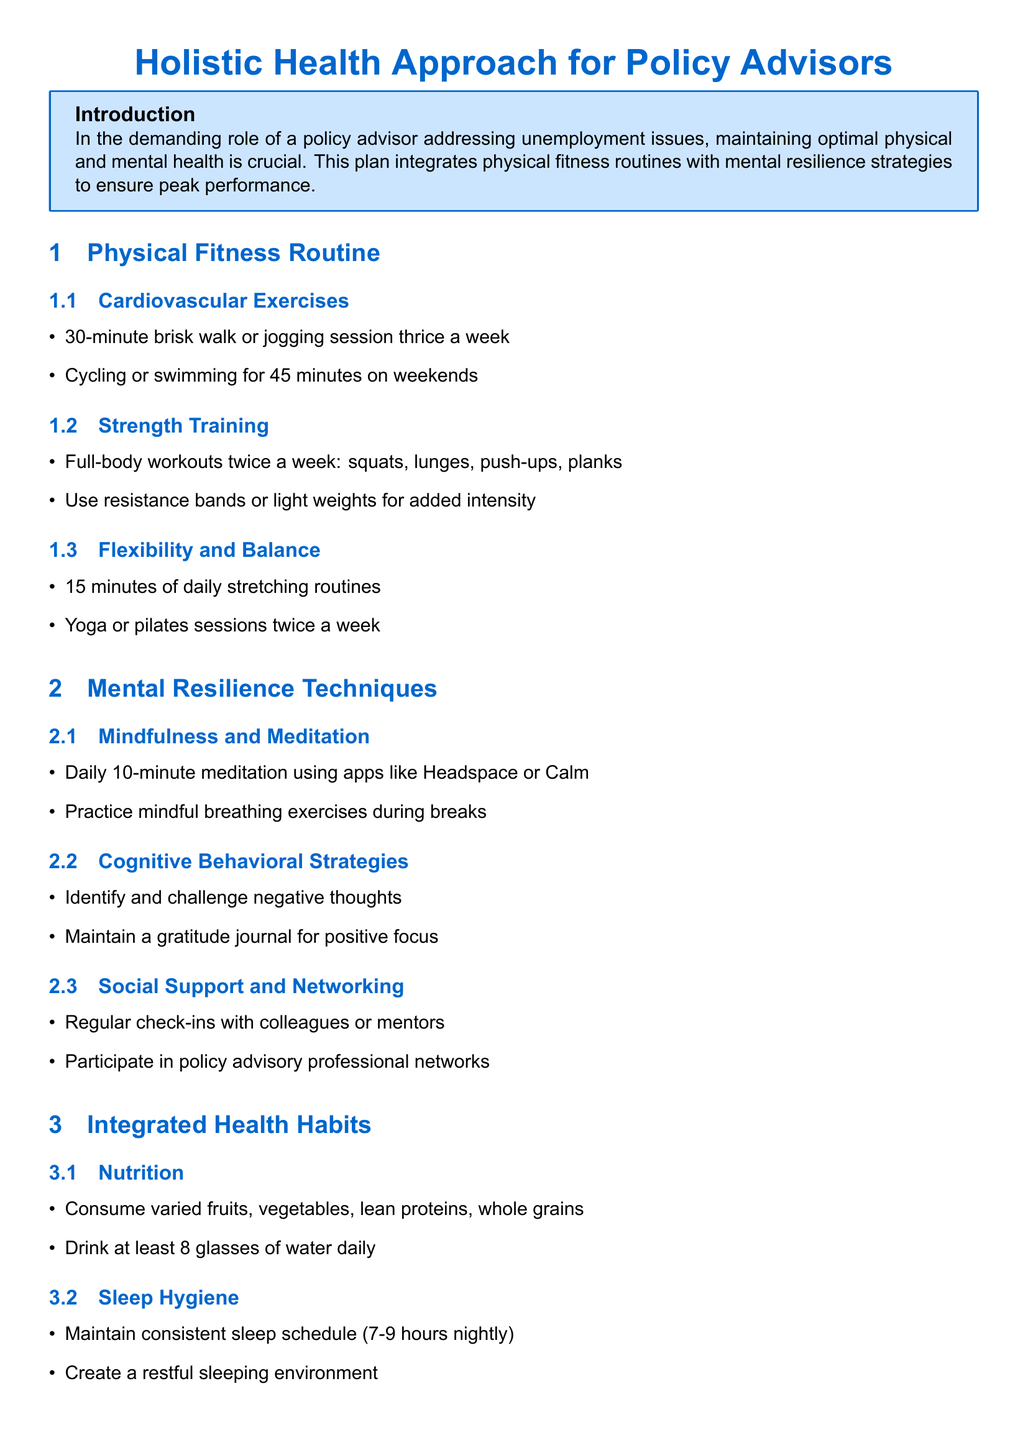what is the recommended frequency for cardiovascular exercises? The document suggests a 30-minute brisk walk or jogging session thrice a week.
Answer: thrice a week how many minutes should be dedicated to daily stretching routines? According to the document, 15 minutes of daily stretching routines are recommended.
Answer: 15 minutes what are two activities recommended for flexibility and balance? The document mentions daily stretching and yoga or pilates sessions twice a week.
Answer: yoga or pilates which app is suggested for daily meditation? The document lists Headspace and Calm as apps for meditation.
Answer: Headspace or Calm what should be maintained for a good sleep hygiene? The document suggests maintaining a consistent sleep schedule of 7-9 hours nightly.
Answer: 7-9 hours nightly what is one cognitive behavioral strategy mentioned? The document advises identifying and challenging negative thoughts as a cognitive behavioral strategy.
Answer: challenge negative thoughts what is the main purpose of the holistic health approach outlined in the document? The conclusion states that the approach equips policy advisors to handle demands of addressing unemployment while maintaining personal well-being.
Answer: personal well-being how often should full-body workouts be performed? The plan recommends full-body workouts twice a week.
Answer: twice a week what is a key aspect of social support in the workplace? Engaging in regular check-ins with colleagues or mentors is emphasized in the document.
Answer: check-ins with colleagues or mentors 